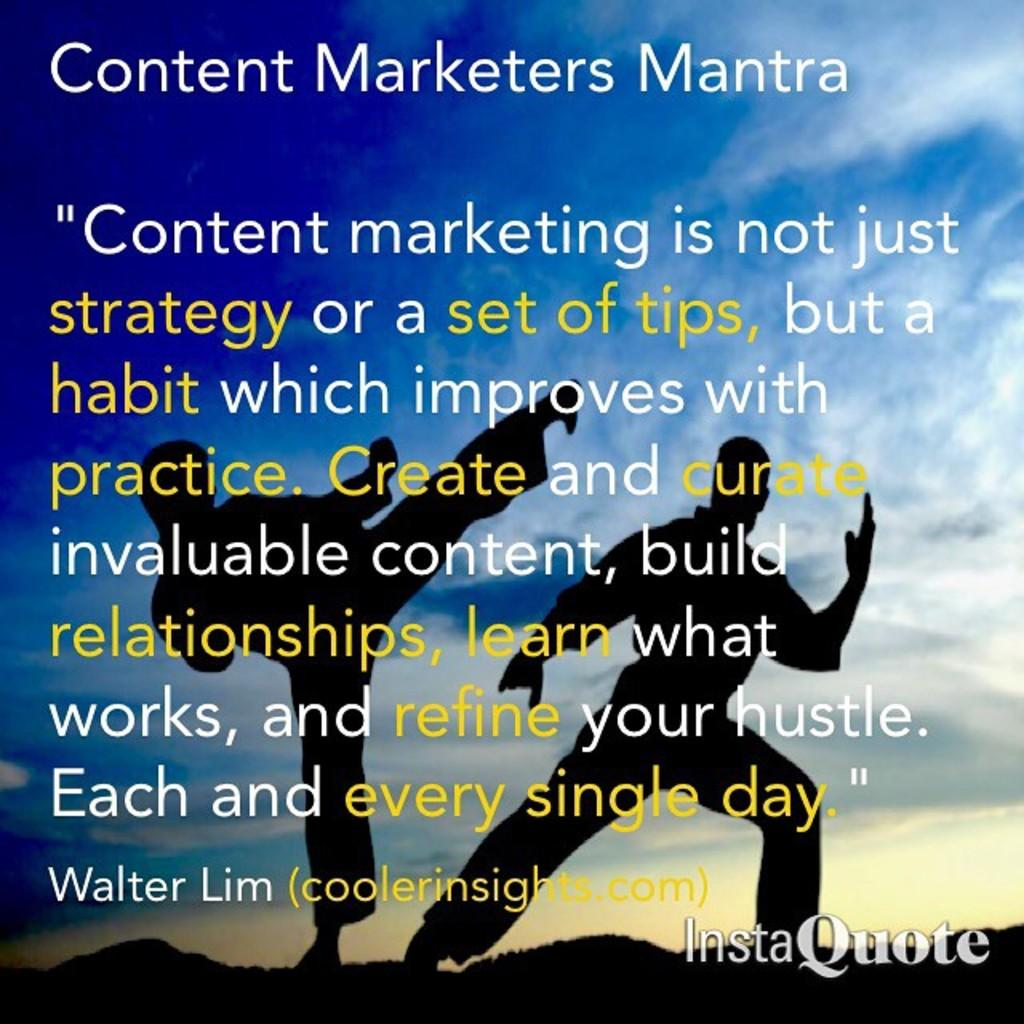Provide a one-sentence caption for the provided image. A slide showing information about the content marketers mantra. 